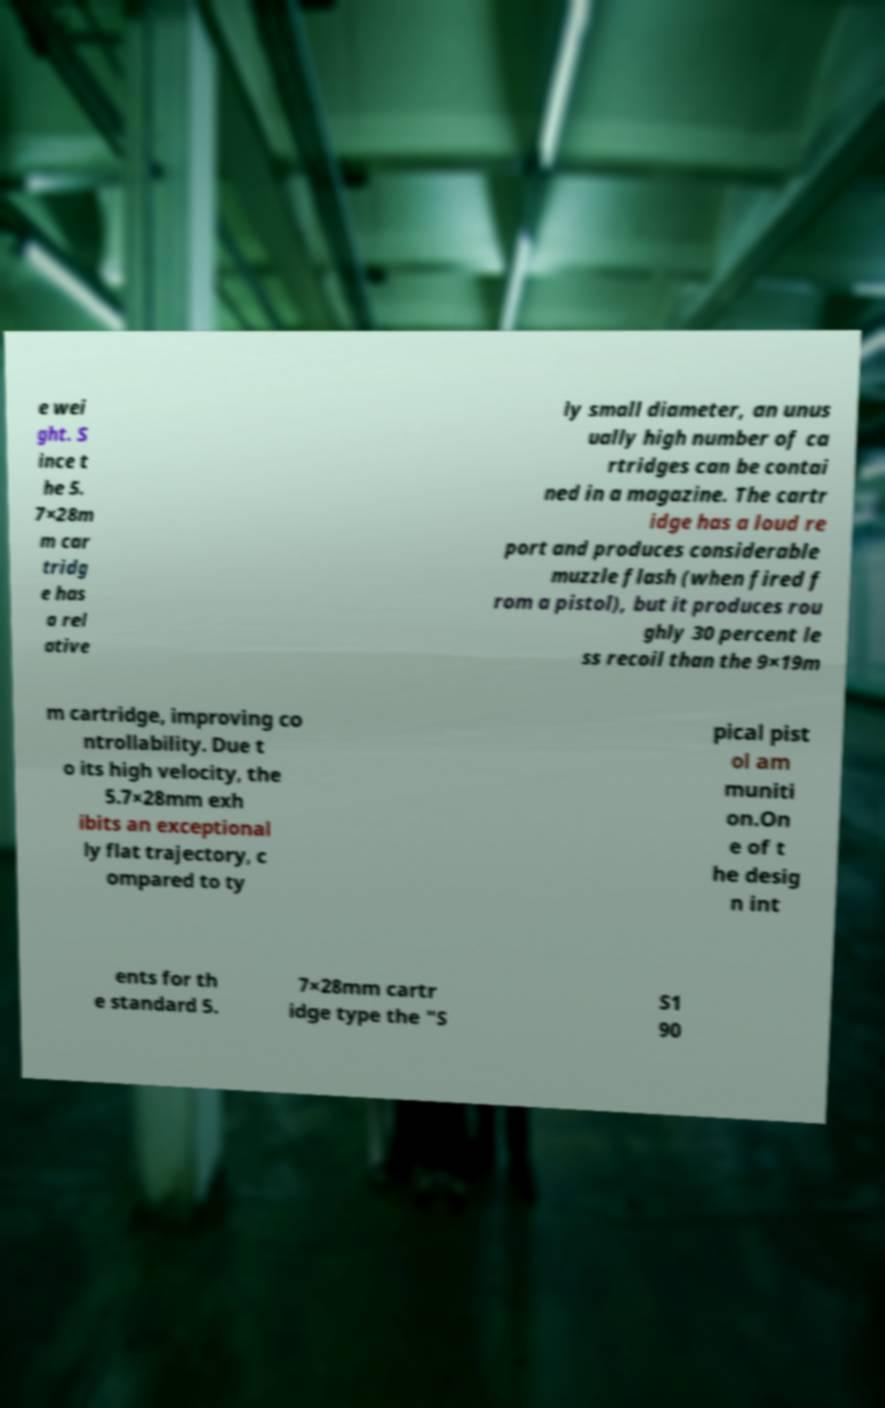Can you accurately transcribe the text from the provided image for me? e wei ght. S ince t he 5. 7×28m m car tridg e has a rel ative ly small diameter, an unus ually high number of ca rtridges can be contai ned in a magazine. The cartr idge has a loud re port and produces considerable muzzle flash (when fired f rom a pistol), but it produces rou ghly 30 percent le ss recoil than the 9×19m m cartridge, improving co ntrollability. Due t o its high velocity, the 5.7×28mm exh ibits an exceptional ly flat trajectory, c ompared to ty pical pist ol am muniti on.On e of t he desig n int ents for th e standard 5. 7×28mm cartr idge type the "S S1 90 